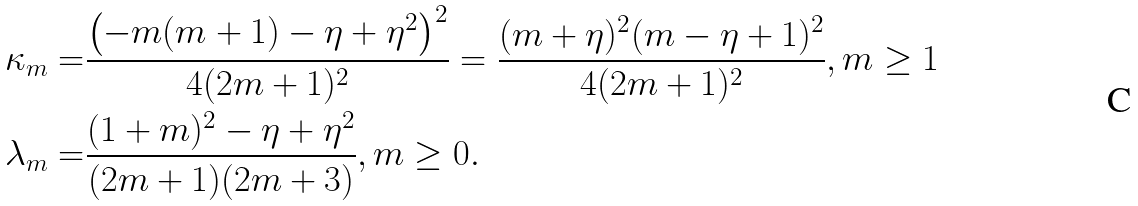<formula> <loc_0><loc_0><loc_500><loc_500>\kappa _ { m } = & \frac { \left ( - m ( m + 1 ) - \eta + \eta ^ { 2 } \right ) ^ { 2 } } { 4 ( 2 m + 1 ) ^ { 2 } } = \frac { ( m + \eta ) ^ { 2 } ( m - \eta + 1 ) ^ { 2 } } { 4 ( 2 m + 1 ) ^ { 2 } } , m \geq 1 \\ \lambda _ { m } = & \frac { ( 1 + m ) ^ { 2 } - \eta + \eta ^ { 2 } } { ( 2 m + 1 ) ( 2 m + 3 ) } , m \geq 0 .</formula> 